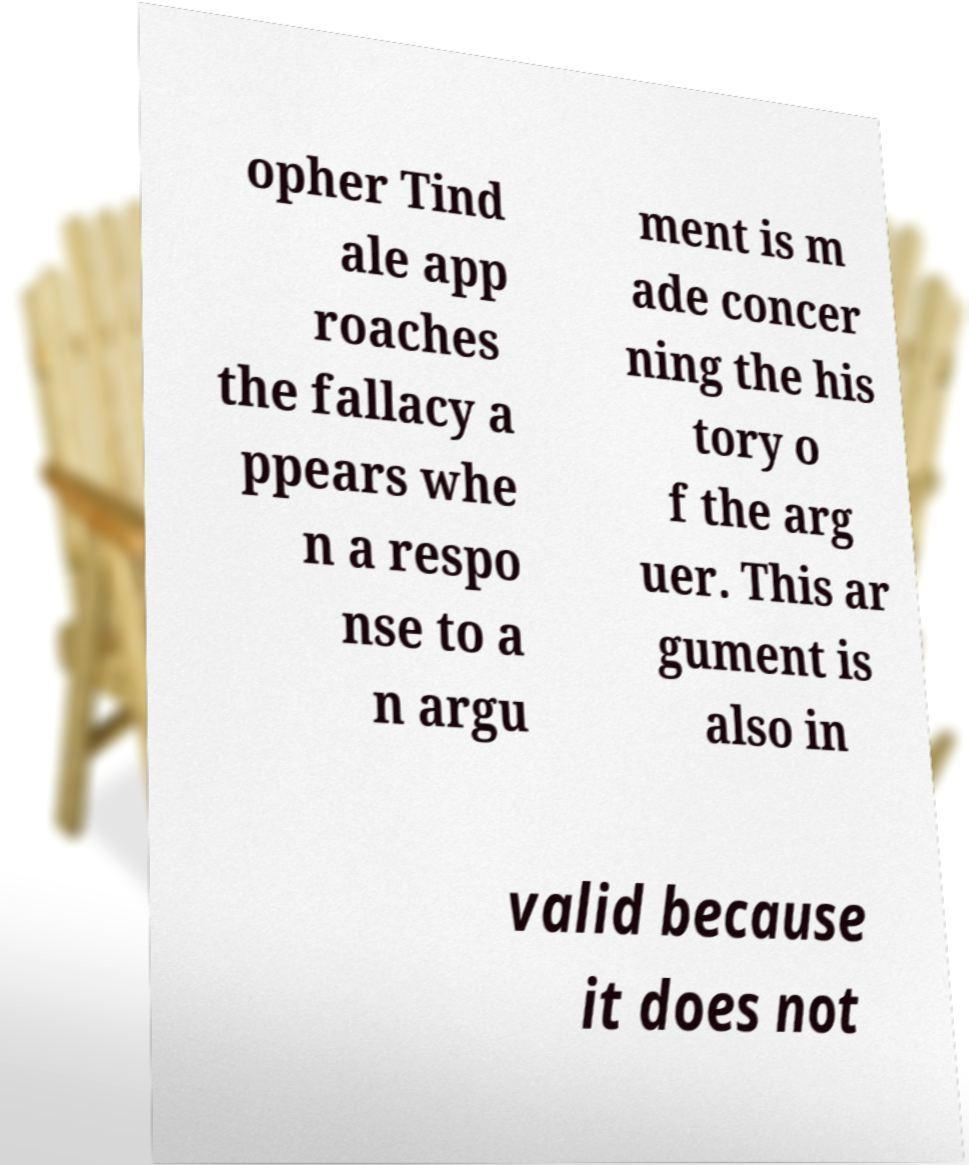Could you assist in decoding the text presented in this image and type it out clearly? opher Tind ale app roaches the fallacy a ppears whe n a respo nse to a n argu ment is m ade concer ning the his tory o f the arg uer. This ar gument is also in valid because it does not 